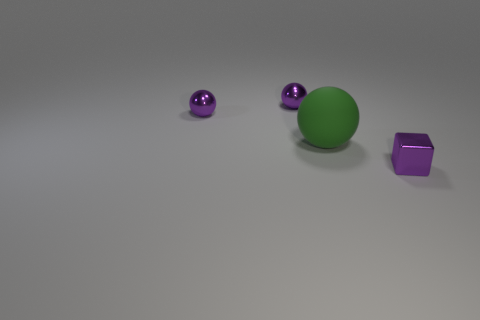Is there any other thing that has the same size as the green rubber ball?
Your response must be concise. No. Is the number of small metallic objects in front of the big thing less than the number of tiny cubes?
Your response must be concise. No. Are there an equal number of green objects that are right of the small metal block and tiny purple objects?
Provide a succinct answer. No. Are there any tiny yellow balls made of the same material as the large green ball?
Offer a terse response. No. What is the small purple object in front of the big green ball made of?
Ensure brevity in your answer.  Metal. How many large balls are the same color as the tiny cube?
Offer a terse response. 0. What number of things are either spheres or tiny metal things?
Give a very brief answer. 4. The small metallic thing that is right of the big green sphere is what color?
Provide a short and direct response. Purple. How many things are metal things on the left side of the big thing or tiny things that are behind the small block?
Provide a succinct answer. 2. There is a green rubber thing; is its shape the same as the tiny purple metal object that is to the right of the matte object?
Your answer should be compact. No. 